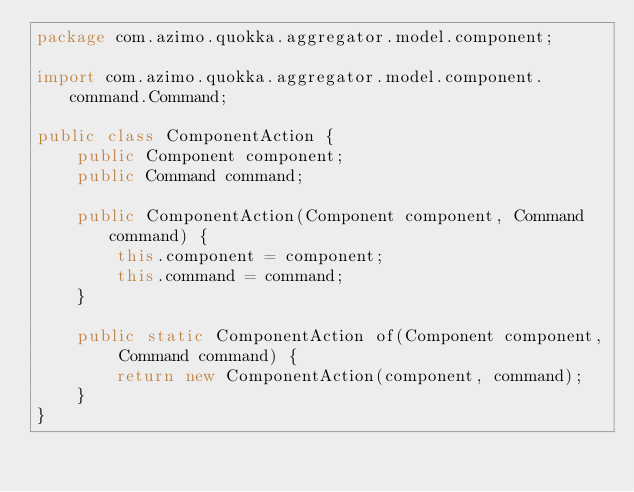Convert code to text. <code><loc_0><loc_0><loc_500><loc_500><_Java_>package com.azimo.quokka.aggregator.model.component;

import com.azimo.quokka.aggregator.model.component.command.Command;

public class ComponentAction {
    public Component component;
    public Command command;

    public ComponentAction(Component component, Command command) {
        this.component = component;
        this.command = command;
    }

    public static ComponentAction of(Component component, Command command) {
        return new ComponentAction(component, command);
    }
}
</code> 